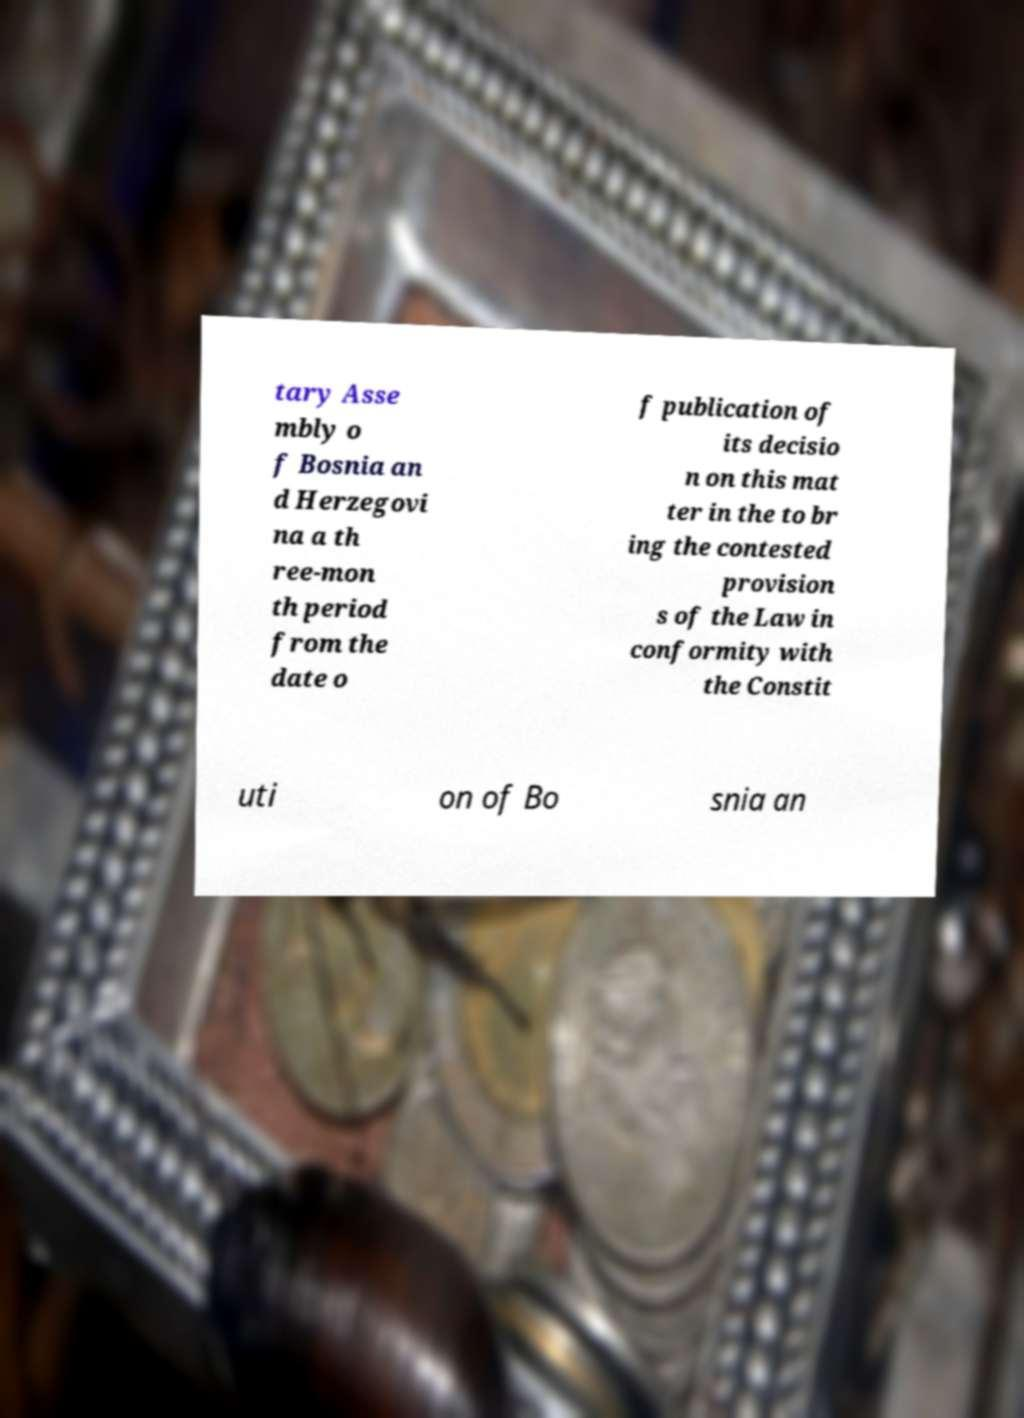What messages or text are displayed in this image? I need them in a readable, typed format. tary Asse mbly o f Bosnia an d Herzegovi na a th ree-mon th period from the date o f publication of its decisio n on this mat ter in the to br ing the contested provision s of the Law in conformity with the Constit uti on of Bo snia an 